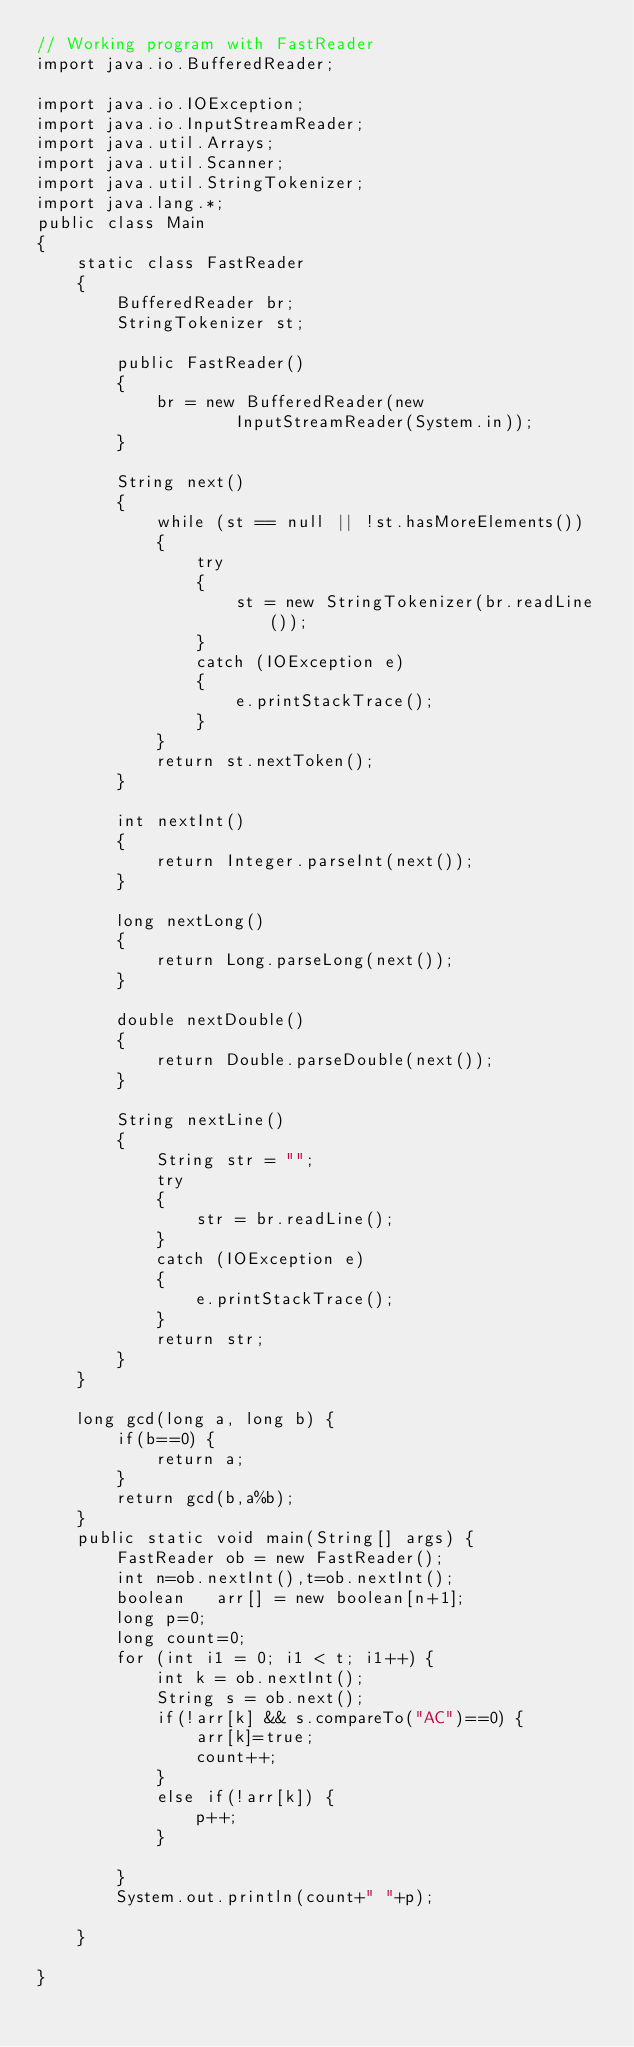Convert code to text. <code><loc_0><loc_0><loc_500><loc_500><_Java_>// Working program with FastReader
import java.io.BufferedReader; 

import java.io.IOException; 
import java.io.InputStreamReader;
import java.util.Arrays;
import java.util.Scanner; 
import java.util.StringTokenizer;
import java.lang.*;
public class Main
{ 
	static class FastReader 
	{ 
		BufferedReader br; 
		StringTokenizer st; 

		public FastReader() 
		{ 
			br = new BufferedReader(new
					InputStreamReader(System.in)); 
		} 

		String next() 
		{ 
			while (st == null || !st.hasMoreElements()) 
			{ 
				try
				{ 
					st = new StringTokenizer(br.readLine()); 
				} 
				catch (IOException e) 
				{ 
					e.printStackTrace(); 
				} 
			} 
			return st.nextToken(); 
		} 

		int nextInt() 
		{ 
			return Integer.parseInt(next()); 
		} 

		long nextLong() 
		{ 
			return Long.parseLong(next()); 
		} 

		double nextDouble() 
		{ 
			return Double.parseDouble(next()); 
		} 

		String nextLine() 
		{ 
			String str = ""; 
			try
			{ 
				str = br.readLine(); 
			} 
			catch (IOException e) 
			{ 
				e.printStackTrace(); 
			} 
			return str; 
		} 
	} 

	long gcd(long a, long b) {
		if(b==0) {
			return a;
		}
		return gcd(b,a%b);
	}
	public static void main(String[] args) {
		FastReader ob = new FastReader();
		int n=ob.nextInt(),t=ob.nextInt();
		boolean   arr[] = new boolean[n+1];
		long p=0;
		long count=0;
		for (int i1 = 0; i1 < t; i1++) {
			int k = ob.nextInt();
			String s = ob.next();
			if(!arr[k] && s.compareTo("AC")==0) {
				arr[k]=true;
				count++;
			}
			else if(!arr[k]) {
				p++;
			}

		}
		System.out.println(count+" "+p);
		
	}

} 
</code> 